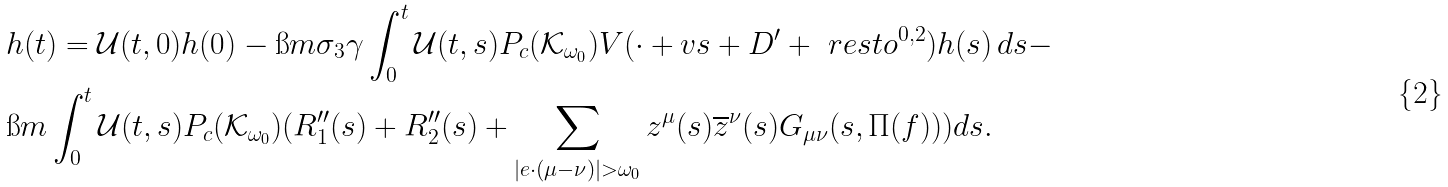<formula> <loc_0><loc_0><loc_500><loc_500>& h ( t ) = \mathcal { U } ( t , 0 ) h ( 0 ) - \i m \sigma _ { 3 } \gamma \int _ { 0 } ^ { t } \mathcal { U } ( t , s ) P _ { c } ( \mathcal { K } _ { \omega _ { 0 } } ) V ( \cdot + v s + D ^ { \prime } + \ r e s t o ^ { 0 , 2 } ) { h } ( s ) \, d s - \\ & \i m \int _ { 0 } ^ { t } \mathcal { U } ( t , s ) P _ { c } ( \mathcal { K } _ { \omega _ { 0 } } ) ( R _ { 1 } ^ { \prime \prime } ( s ) + R _ { 2 } ^ { \prime \prime } ( s ) + \sum _ { | e \cdot ( \mu - \nu ) | > \omega _ { 0 } } z ^ { \mu } ( s ) \overline { z } ^ { \nu } ( s ) G _ { \mu \nu } ( s , \Pi ( f ) ) ) d s .</formula> 